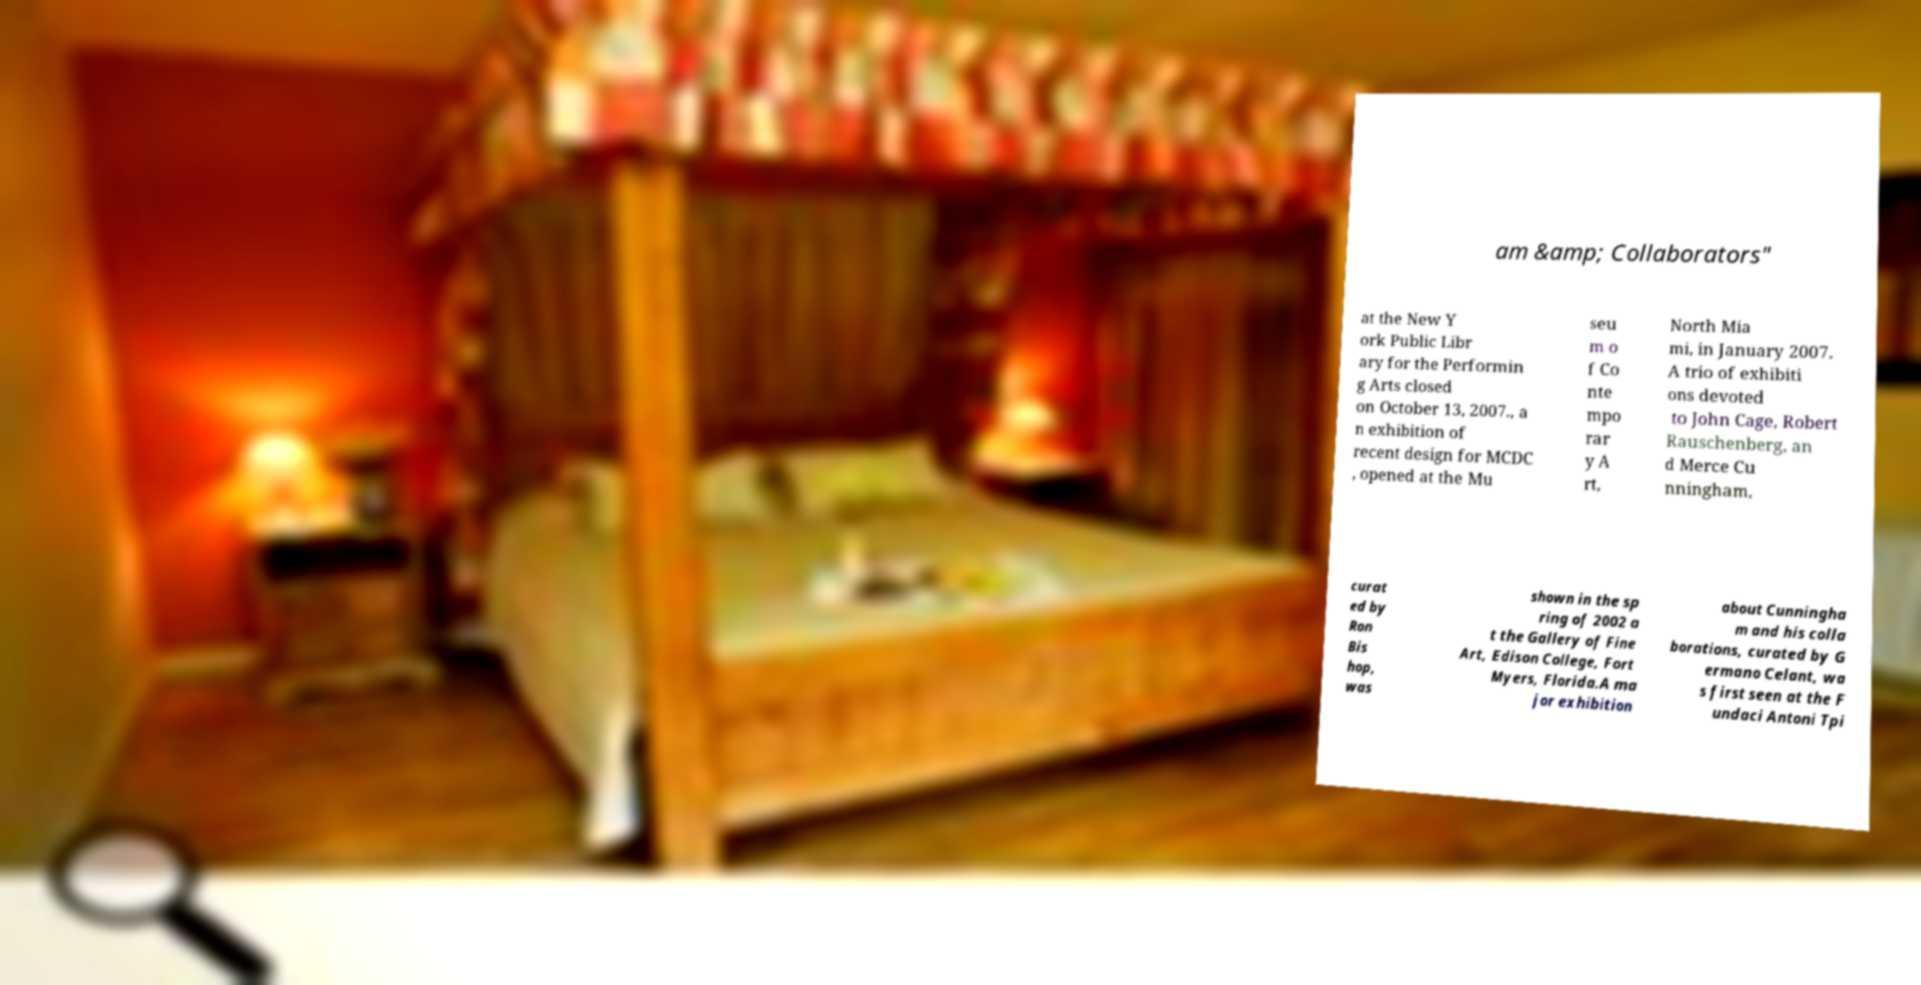Can you accurately transcribe the text from the provided image for me? am &amp; Collaborators" at the New Y ork Public Libr ary for the Performin g Arts closed on October 13, 2007., a n exhibition of recent design for MCDC , opened at the Mu seu m o f Co nte mpo rar y A rt, North Mia mi, in January 2007. A trio of exhibiti ons devoted to John Cage, Robert Rauschenberg, an d Merce Cu nningham, curat ed by Ron Bis hop, was shown in the sp ring of 2002 a t the Gallery of Fine Art, Edison College, Fort Myers, Florida.A ma jor exhibition about Cunningha m and his colla borations, curated by G ermano Celant, wa s first seen at the F undaci Antoni Tpi 